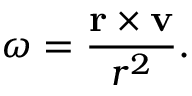<formula> <loc_0><loc_0><loc_500><loc_500>{ \omega } = { \frac { r \times v } { r ^ { 2 } } } .</formula> 